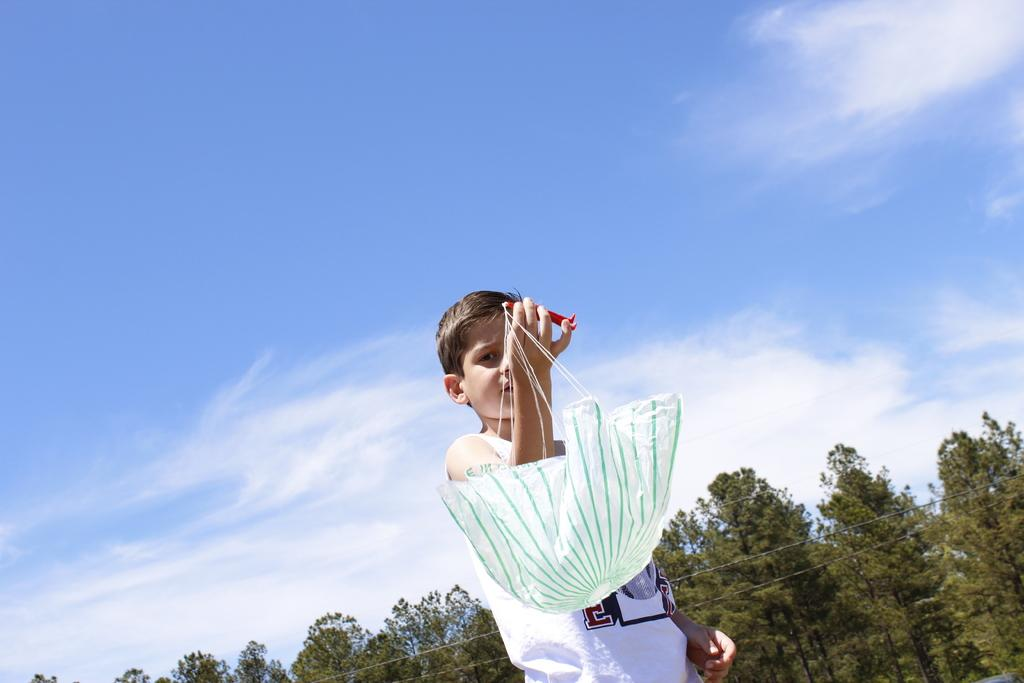What is the person in the image holding? There is a person holding an object in the image. What type of natural environment can be seen in the image? There are trees visible in the image. What else is present in the image besides the person and trees? Wires are present in the image. What is visible in the background of the image? The sky is visible in the image, and clouds are present in the sky. What type of cork can be seen floating in the sky in the image? There is no cork present in the image, and nothing is floating in the sky. 